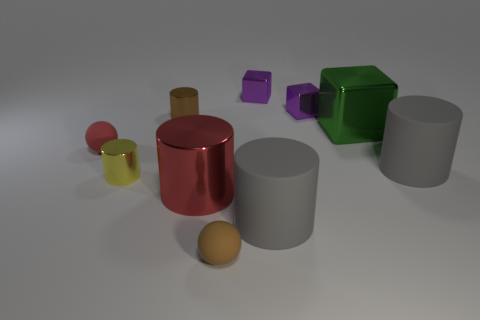How many big things are purple cubes or brown metal things?
Your answer should be compact. 0. How many purple things have the same material as the big red cylinder?
Ensure brevity in your answer.  2. There is a brown thing to the right of the brown shiny object; what size is it?
Provide a short and direct response. Small. There is a tiny brown object that is behind the small rubber ball on the right side of the red matte ball; what is its shape?
Make the answer very short. Cylinder. There is a shiny block in front of the shiny cylinder that is behind the yellow metallic cylinder; how many large gray rubber objects are to the right of it?
Offer a terse response. 1. Are there fewer things that are left of the small yellow metal thing than brown objects?
Make the answer very short. Yes. Is there anything else that is the same shape as the red metallic thing?
Make the answer very short. Yes. What is the shape of the big metallic object behind the yellow thing?
Make the answer very short. Cube. The small metallic object that is to the left of the cylinder that is behind the ball that is on the left side of the red metal thing is what shape?
Provide a short and direct response. Cylinder. How many things are gray cylinders or yellow objects?
Give a very brief answer. 3. 